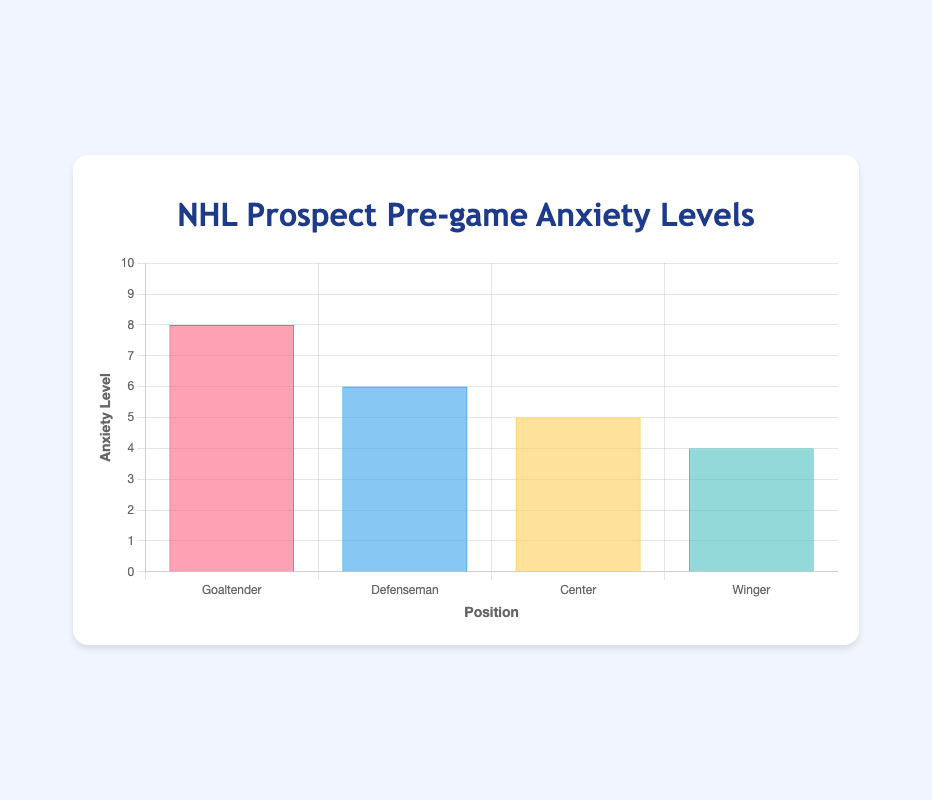what is the highest anxiety level shown in the chart? The highest anxiety level is the maximum value among all the data points. From the chart, the Goaltender position has an anxiety level of 8, which is the highest.
Answer: 8 what position has the lowest pre-game anxiety level? To find the position with the lowest anxiety level, look for the position with the smallest value. Here, the Winger has the smallest value, which is 4.
Answer: Winger Which notable prospect is associated with the Goaltender's anxiety level? Spencer Knight is the notable prospect shown for the Goaltender. This can be identified from the tooltip information mapped to the chart data.
Answer: Spencer Knight How much higher is the Defenseman's anxiety compared to the Winger's anxiety? The Defenseman's anxiety level is 6, and the Winger's anxiety level is 4. The difference is calculated by subtracting 4 from 6.
Answer: 2 What facial expression emoji represents the Center's pre-game anxiety level? The chart represents the Center's anxiety level of 5 with the emoji "😐".
Answer: 😐 Which position has an anxiety level of 6? From the chart, the Defenseman position has an anxiety level of 6.
Answer: Defenseman Is the anxiety level of Center higher or lower than Defenseman? The Center has an anxiety level of 5, and the Defenseman has 6. Therefore, the Center's level is lower.
Answer: Lower What is the average pre-game anxiety level of all positions? The anxiety levels are 8 (Goaltender), 6 (Defenseman), 5 (Center), and 4 (Winger). The average is calculated as (8 + 6 + 5 + 4) / 4 = 5.75.
Answer: 5.75 Which position has the emoji "🙂" and what is its corresponding anxiety level? The emoji "🙂" is associated with the Winger, who has an anxiety level of 4.
Answer: Winger, 4 